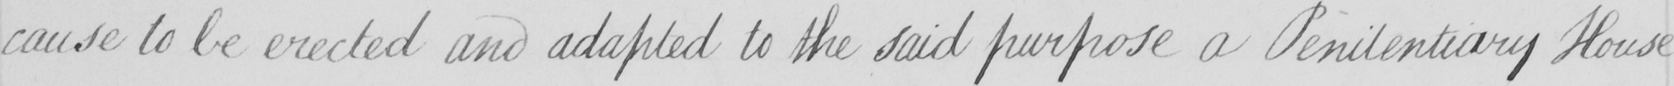What text is written in this handwritten line? cause to be erected and adapted to the said purpose a Penitentiary House 